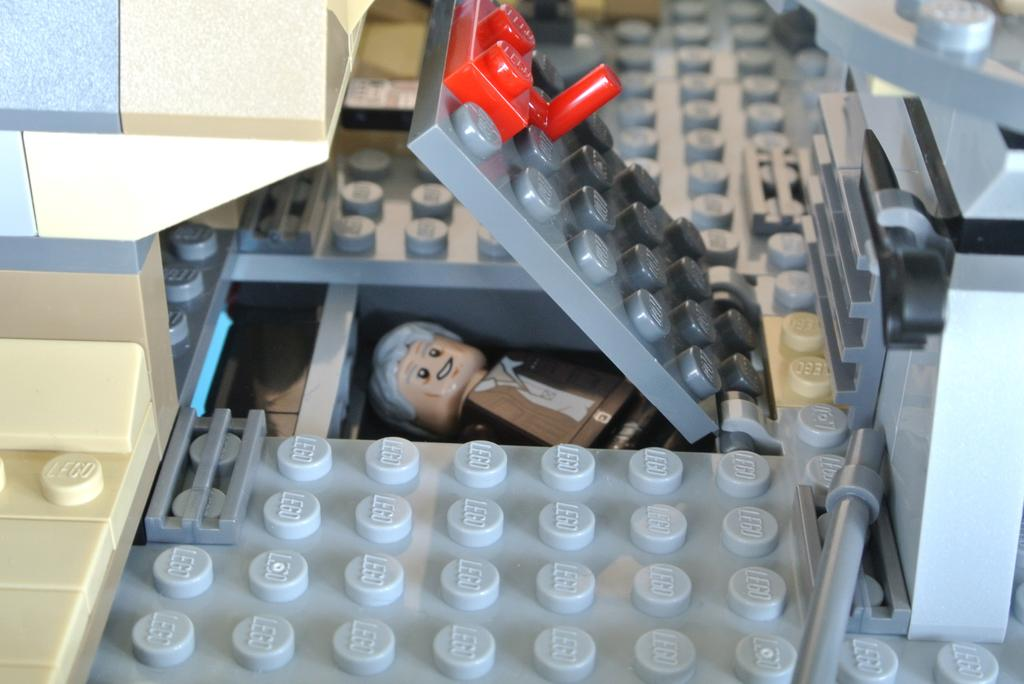What type of toys are visible in the image? There are Lego toys in the image. What other type of toy can be seen in the image? There is a person's doll in the image. What type of substance is being used to create the playground in the image? There is no playground present in the image, so it is not possible to determine what substance might be used to create one. 